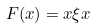<formula> <loc_0><loc_0><loc_500><loc_500>F ( x ) = x \xi x</formula> 